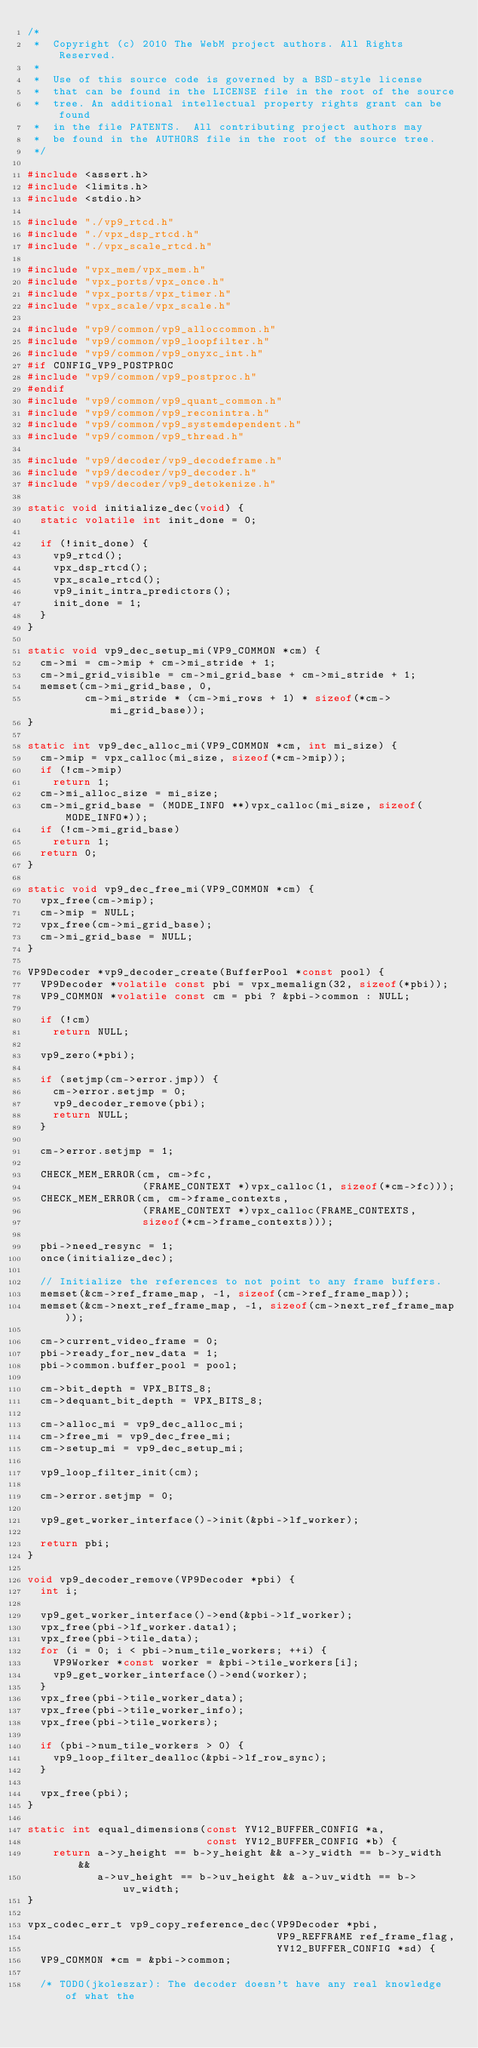<code> <loc_0><loc_0><loc_500><loc_500><_C_>/*
 *  Copyright (c) 2010 The WebM project authors. All Rights Reserved.
 *
 *  Use of this source code is governed by a BSD-style license
 *  that can be found in the LICENSE file in the root of the source
 *  tree. An additional intellectual property rights grant can be found
 *  in the file PATENTS.  All contributing project authors may
 *  be found in the AUTHORS file in the root of the source tree.
 */

#include <assert.h>
#include <limits.h>
#include <stdio.h>

#include "./vp9_rtcd.h"
#include "./vpx_dsp_rtcd.h"
#include "./vpx_scale_rtcd.h"

#include "vpx_mem/vpx_mem.h"
#include "vpx_ports/vpx_once.h"
#include "vpx_ports/vpx_timer.h"
#include "vpx_scale/vpx_scale.h"

#include "vp9/common/vp9_alloccommon.h"
#include "vp9/common/vp9_loopfilter.h"
#include "vp9/common/vp9_onyxc_int.h"
#if CONFIG_VP9_POSTPROC
#include "vp9/common/vp9_postproc.h"
#endif
#include "vp9/common/vp9_quant_common.h"
#include "vp9/common/vp9_reconintra.h"
#include "vp9/common/vp9_systemdependent.h"
#include "vp9/common/vp9_thread.h"

#include "vp9/decoder/vp9_decodeframe.h"
#include "vp9/decoder/vp9_decoder.h"
#include "vp9/decoder/vp9_detokenize.h"

static void initialize_dec(void) {
  static volatile int init_done = 0;

  if (!init_done) {
    vp9_rtcd();
    vpx_dsp_rtcd();
    vpx_scale_rtcd();
    vp9_init_intra_predictors();
    init_done = 1;
  }
}

static void vp9_dec_setup_mi(VP9_COMMON *cm) {
  cm->mi = cm->mip + cm->mi_stride + 1;
  cm->mi_grid_visible = cm->mi_grid_base + cm->mi_stride + 1;
  memset(cm->mi_grid_base, 0,
         cm->mi_stride * (cm->mi_rows + 1) * sizeof(*cm->mi_grid_base));
}

static int vp9_dec_alloc_mi(VP9_COMMON *cm, int mi_size) {
  cm->mip = vpx_calloc(mi_size, sizeof(*cm->mip));
  if (!cm->mip)
    return 1;
  cm->mi_alloc_size = mi_size;
  cm->mi_grid_base = (MODE_INFO **)vpx_calloc(mi_size, sizeof(MODE_INFO*));
  if (!cm->mi_grid_base)
    return 1;
  return 0;
}

static void vp9_dec_free_mi(VP9_COMMON *cm) {
  vpx_free(cm->mip);
  cm->mip = NULL;
  vpx_free(cm->mi_grid_base);
  cm->mi_grid_base = NULL;
}

VP9Decoder *vp9_decoder_create(BufferPool *const pool) {
  VP9Decoder *volatile const pbi = vpx_memalign(32, sizeof(*pbi));
  VP9_COMMON *volatile const cm = pbi ? &pbi->common : NULL;

  if (!cm)
    return NULL;

  vp9_zero(*pbi);

  if (setjmp(cm->error.jmp)) {
    cm->error.setjmp = 0;
    vp9_decoder_remove(pbi);
    return NULL;
  }

  cm->error.setjmp = 1;

  CHECK_MEM_ERROR(cm, cm->fc,
                  (FRAME_CONTEXT *)vpx_calloc(1, sizeof(*cm->fc)));
  CHECK_MEM_ERROR(cm, cm->frame_contexts,
                  (FRAME_CONTEXT *)vpx_calloc(FRAME_CONTEXTS,
                  sizeof(*cm->frame_contexts)));

  pbi->need_resync = 1;
  once(initialize_dec);

  // Initialize the references to not point to any frame buffers.
  memset(&cm->ref_frame_map, -1, sizeof(cm->ref_frame_map));
  memset(&cm->next_ref_frame_map, -1, sizeof(cm->next_ref_frame_map));

  cm->current_video_frame = 0;
  pbi->ready_for_new_data = 1;
  pbi->common.buffer_pool = pool;

  cm->bit_depth = VPX_BITS_8;
  cm->dequant_bit_depth = VPX_BITS_8;

  cm->alloc_mi = vp9_dec_alloc_mi;
  cm->free_mi = vp9_dec_free_mi;
  cm->setup_mi = vp9_dec_setup_mi;

  vp9_loop_filter_init(cm);

  cm->error.setjmp = 0;

  vp9_get_worker_interface()->init(&pbi->lf_worker);

  return pbi;
}

void vp9_decoder_remove(VP9Decoder *pbi) {
  int i;

  vp9_get_worker_interface()->end(&pbi->lf_worker);
  vpx_free(pbi->lf_worker.data1);
  vpx_free(pbi->tile_data);
  for (i = 0; i < pbi->num_tile_workers; ++i) {
    VP9Worker *const worker = &pbi->tile_workers[i];
    vp9_get_worker_interface()->end(worker);
  }
  vpx_free(pbi->tile_worker_data);
  vpx_free(pbi->tile_worker_info);
  vpx_free(pbi->tile_workers);

  if (pbi->num_tile_workers > 0) {
    vp9_loop_filter_dealloc(&pbi->lf_row_sync);
  }

  vpx_free(pbi);
}

static int equal_dimensions(const YV12_BUFFER_CONFIG *a,
                            const YV12_BUFFER_CONFIG *b) {
    return a->y_height == b->y_height && a->y_width == b->y_width &&
           a->uv_height == b->uv_height && a->uv_width == b->uv_width;
}

vpx_codec_err_t vp9_copy_reference_dec(VP9Decoder *pbi,
                                       VP9_REFFRAME ref_frame_flag,
                                       YV12_BUFFER_CONFIG *sd) {
  VP9_COMMON *cm = &pbi->common;

  /* TODO(jkoleszar): The decoder doesn't have any real knowledge of what the</code> 